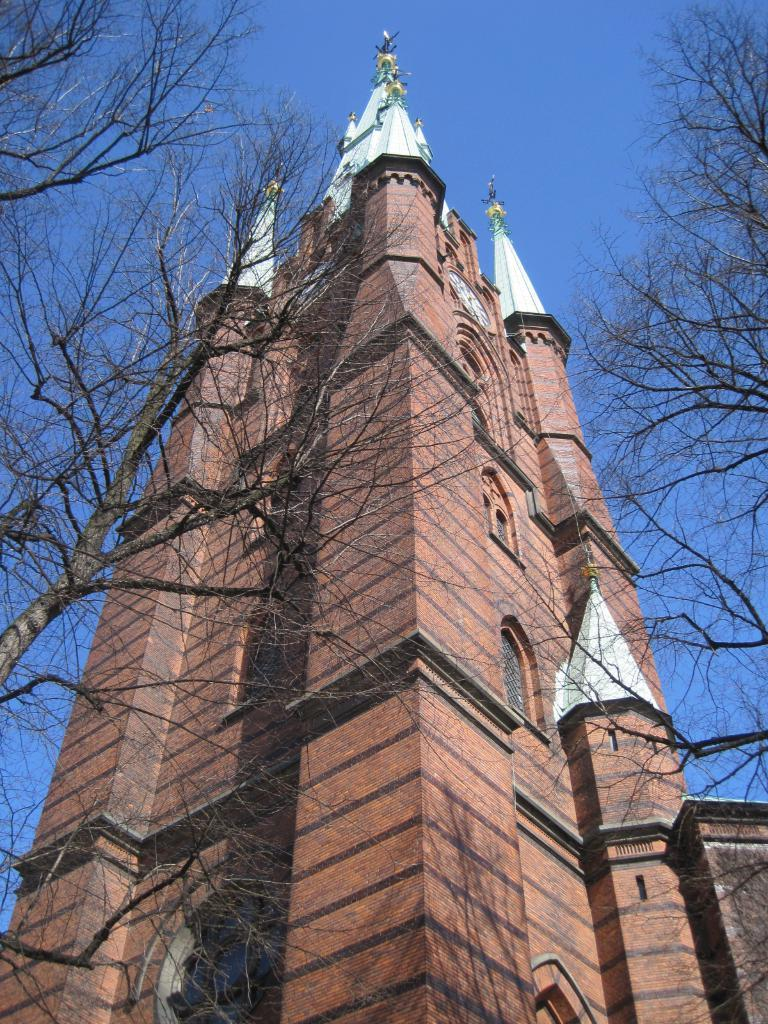What is the main structure in the middle of the image? There is a big building in the middle of the image. What type of vegetation is present on both sides of the image? There are trees on either side of the image. What is visible at the top of the image? The sky is visible at the top of the image. How many feet are visible in the image? There are no feet visible in the image. What type of nest can be seen in the trees on either side of the image? There are no nests present in the image; only trees are visible. 